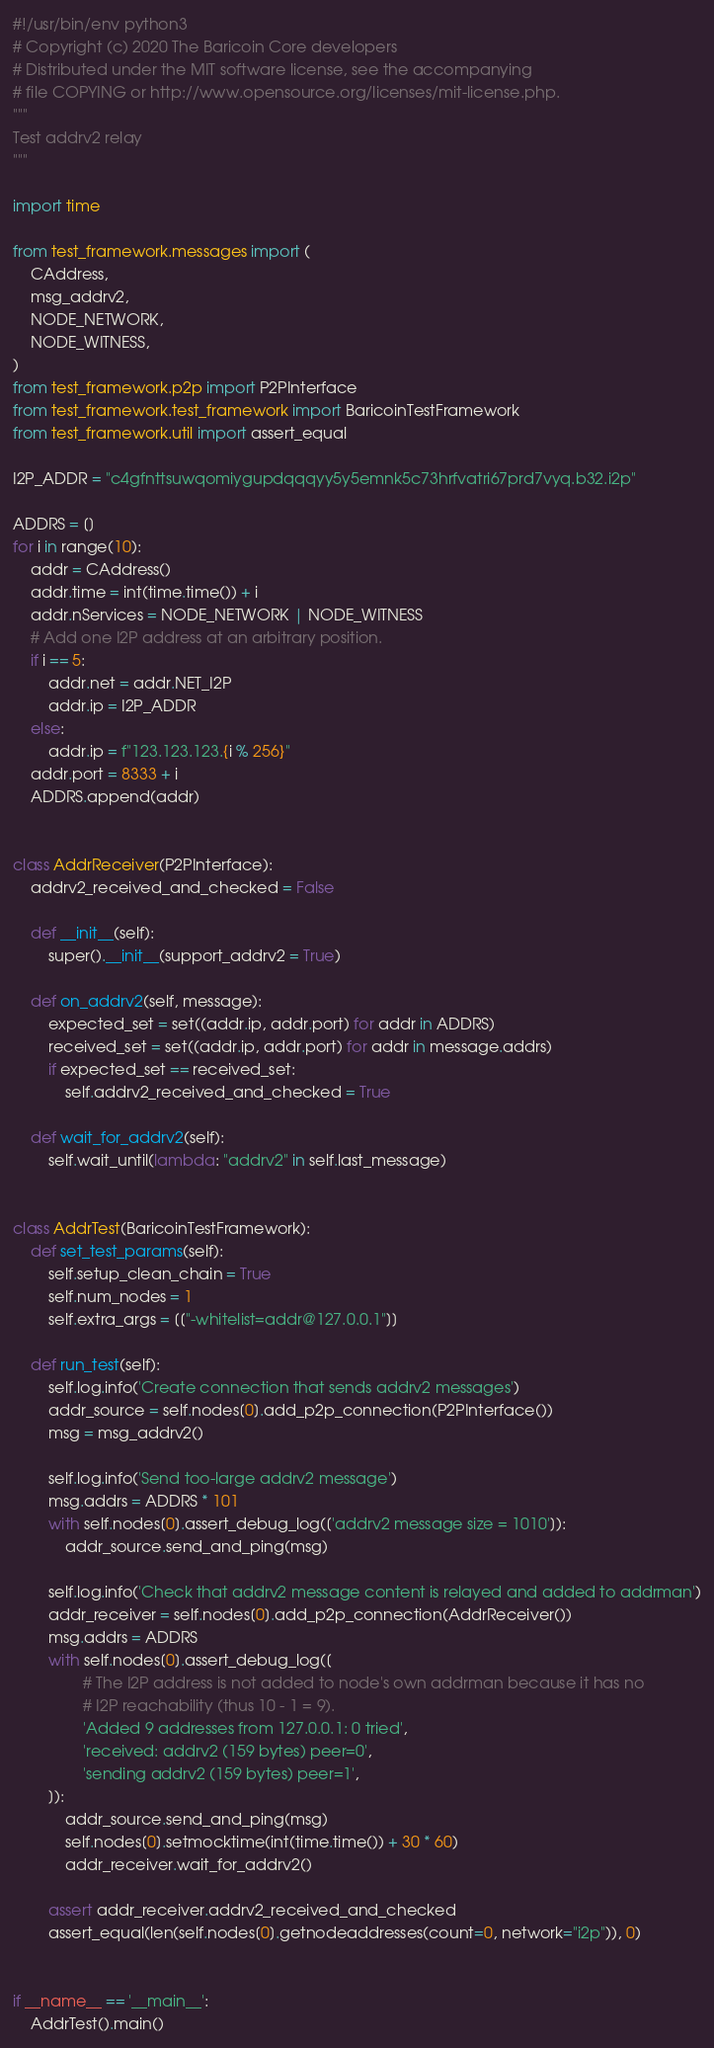<code> <loc_0><loc_0><loc_500><loc_500><_Python_>#!/usr/bin/env python3
# Copyright (c) 2020 The Baricoin Core developers
# Distributed under the MIT software license, see the accompanying
# file COPYING or http://www.opensource.org/licenses/mit-license.php.
"""
Test addrv2 relay
"""

import time

from test_framework.messages import (
    CAddress,
    msg_addrv2,
    NODE_NETWORK,
    NODE_WITNESS,
)
from test_framework.p2p import P2PInterface
from test_framework.test_framework import BaricoinTestFramework
from test_framework.util import assert_equal

I2P_ADDR = "c4gfnttsuwqomiygupdqqqyy5y5emnk5c73hrfvatri67prd7vyq.b32.i2p"

ADDRS = []
for i in range(10):
    addr = CAddress()
    addr.time = int(time.time()) + i
    addr.nServices = NODE_NETWORK | NODE_WITNESS
    # Add one I2P address at an arbitrary position.
    if i == 5:
        addr.net = addr.NET_I2P
        addr.ip = I2P_ADDR
    else:
        addr.ip = f"123.123.123.{i % 256}"
    addr.port = 8333 + i
    ADDRS.append(addr)


class AddrReceiver(P2PInterface):
    addrv2_received_and_checked = False

    def __init__(self):
        super().__init__(support_addrv2 = True)

    def on_addrv2(self, message):
        expected_set = set((addr.ip, addr.port) for addr in ADDRS)
        received_set = set((addr.ip, addr.port) for addr in message.addrs)
        if expected_set == received_set:
            self.addrv2_received_and_checked = True

    def wait_for_addrv2(self):
        self.wait_until(lambda: "addrv2" in self.last_message)


class AddrTest(BaricoinTestFramework):
    def set_test_params(self):
        self.setup_clean_chain = True
        self.num_nodes = 1
        self.extra_args = [["-whitelist=addr@127.0.0.1"]]

    def run_test(self):
        self.log.info('Create connection that sends addrv2 messages')
        addr_source = self.nodes[0].add_p2p_connection(P2PInterface())
        msg = msg_addrv2()

        self.log.info('Send too-large addrv2 message')
        msg.addrs = ADDRS * 101
        with self.nodes[0].assert_debug_log(['addrv2 message size = 1010']):
            addr_source.send_and_ping(msg)

        self.log.info('Check that addrv2 message content is relayed and added to addrman')
        addr_receiver = self.nodes[0].add_p2p_connection(AddrReceiver())
        msg.addrs = ADDRS
        with self.nodes[0].assert_debug_log([
                # The I2P address is not added to node's own addrman because it has no
                # I2P reachability (thus 10 - 1 = 9).
                'Added 9 addresses from 127.0.0.1: 0 tried',
                'received: addrv2 (159 bytes) peer=0',
                'sending addrv2 (159 bytes) peer=1',
        ]):
            addr_source.send_and_ping(msg)
            self.nodes[0].setmocktime(int(time.time()) + 30 * 60)
            addr_receiver.wait_for_addrv2()

        assert addr_receiver.addrv2_received_and_checked
        assert_equal(len(self.nodes[0].getnodeaddresses(count=0, network="i2p")), 0)


if __name__ == '__main__':
    AddrTest().main()
</code> 